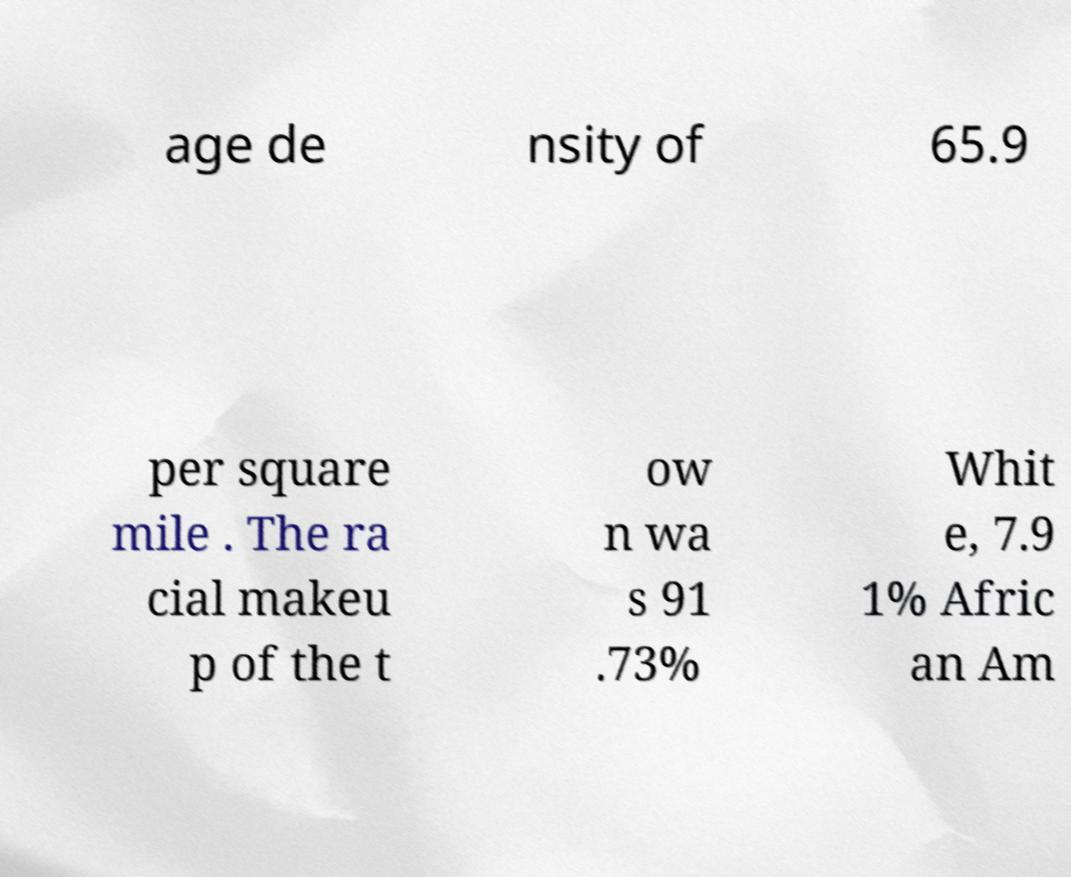Please read and relay the text visible in this image. What does it say? age de nsity of 65.9 per square mile . The ra cial makeu p of the t ow n wa s 91 .73% Whit e, 7.9 1% Afric an Am 